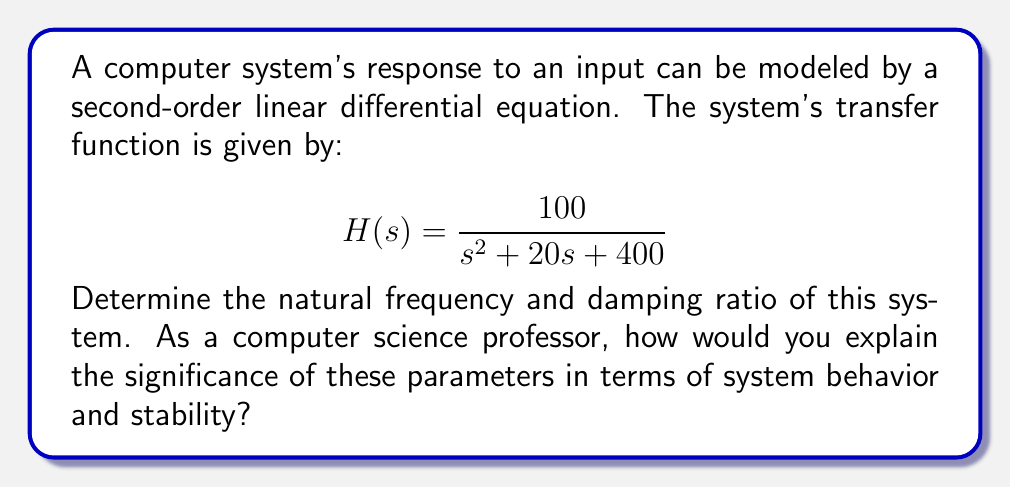Teach me how to tackle this problem. To determine the natural frequency and damping ratio, we need to compare the given transfer function to the standard form of a second-order system:

$$H(s) = \frac{\omega_n^2}{s^2 + 2\zeta\omega_n s + \omega_n^2}$$

Where $\omega_n$ is the natural frequency and $\zeta$ is the damping ratio.

Step 1: Identify the coefficients
In our system:
$$H(s) = \frac{100}{s^2 + 20s + 400}$$

Comparing this to the standard form, we can see that:
- $\omega_n^2 = 400$
- $2\zeta\omega_n = 20$

Step 2: Calculate the natural frequency $\omega_n$
$$\omega_n = \sqrt{400} = 20 \text{ rad/s}$$

Step 3: Calculate the damping ratio $\zeta$
Using $2\zeta\omega_n = 20$ and $\omega_n = 20$:
$$2\zeta(20) = 20$$
$$\zeta = \frac{20}{40} = 0.5$$

Significance in system behavior and stability:

1. Natural frequency ($\omega_n$): This represents the frequency at which the system would oscillate if there were no damping. In computer systems, it can be related to the system's responsiveness or the speed at which it can process and respond to inputs.

2. Damping ratio ($\zeta$):
   - $\zeta < 1$: Underdamped system (oscillates before settling)
   - $\zeta = 1$: Critically damped system (fastest settling without oscillation)
   - $\zeta > 1$: Overdamped system (slow settling without oscillation)

In this case, $\zeta = 0.5$, indicating an underdamped system. This means the system will oscillate before settling to its final value, which could lead to potential overshooting in computer systems. Understanding these parameters is crucial for designing stable and responsive computer systems, especially in areas like control systems, real-time processing, and user interface responsiveness.
Answer: Natural frequency: $\omega_n = 20 \text{ rad/s}$
Damping ratio: $\zeta = 0.5$ 